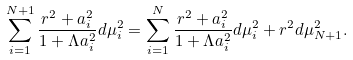Convert formula to latex. <formula><loc_0><loc_0><loc_500><loc_500>\sum _ { i = 1 } ^ { N + 1 } \frac { r ^ { 2 } + a _ { i } ^ { 2 } } { 1 + \Lambda a _ { i } ^ { 2 } } d \mu _ { i } ^ { 2 } = \sum _ { i = 1 } ^ { N } \frac { r ^ { 2 } + a _ { i } ^ { 2 } } { 1 + \Lambda a _ { i } ^ { 2 } } d \mu _ { i } ^ { 2 } + r ^ { 2 } d \mu _ { N + 1 } ^ { 2 } .</formula> 